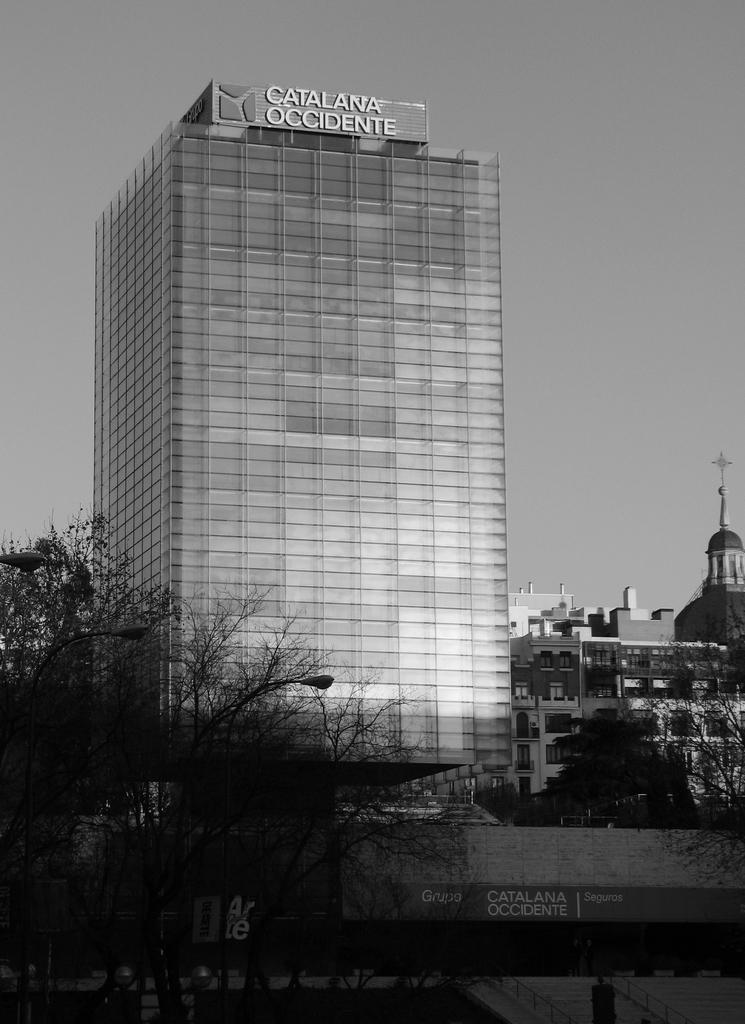What is the color scheme of the image? The image is black and white. What type of structures can be seen in the image? There are buildings in the image. What other objects are present in the image? There are poles, lights, and trees in the image. What can be seen in the background of the image? The sky is visible in the background of the image. Where is the stone field located in the image? There is no stone field present in the image. Can you describe the river that runs through the image? There is no river present in the image. 